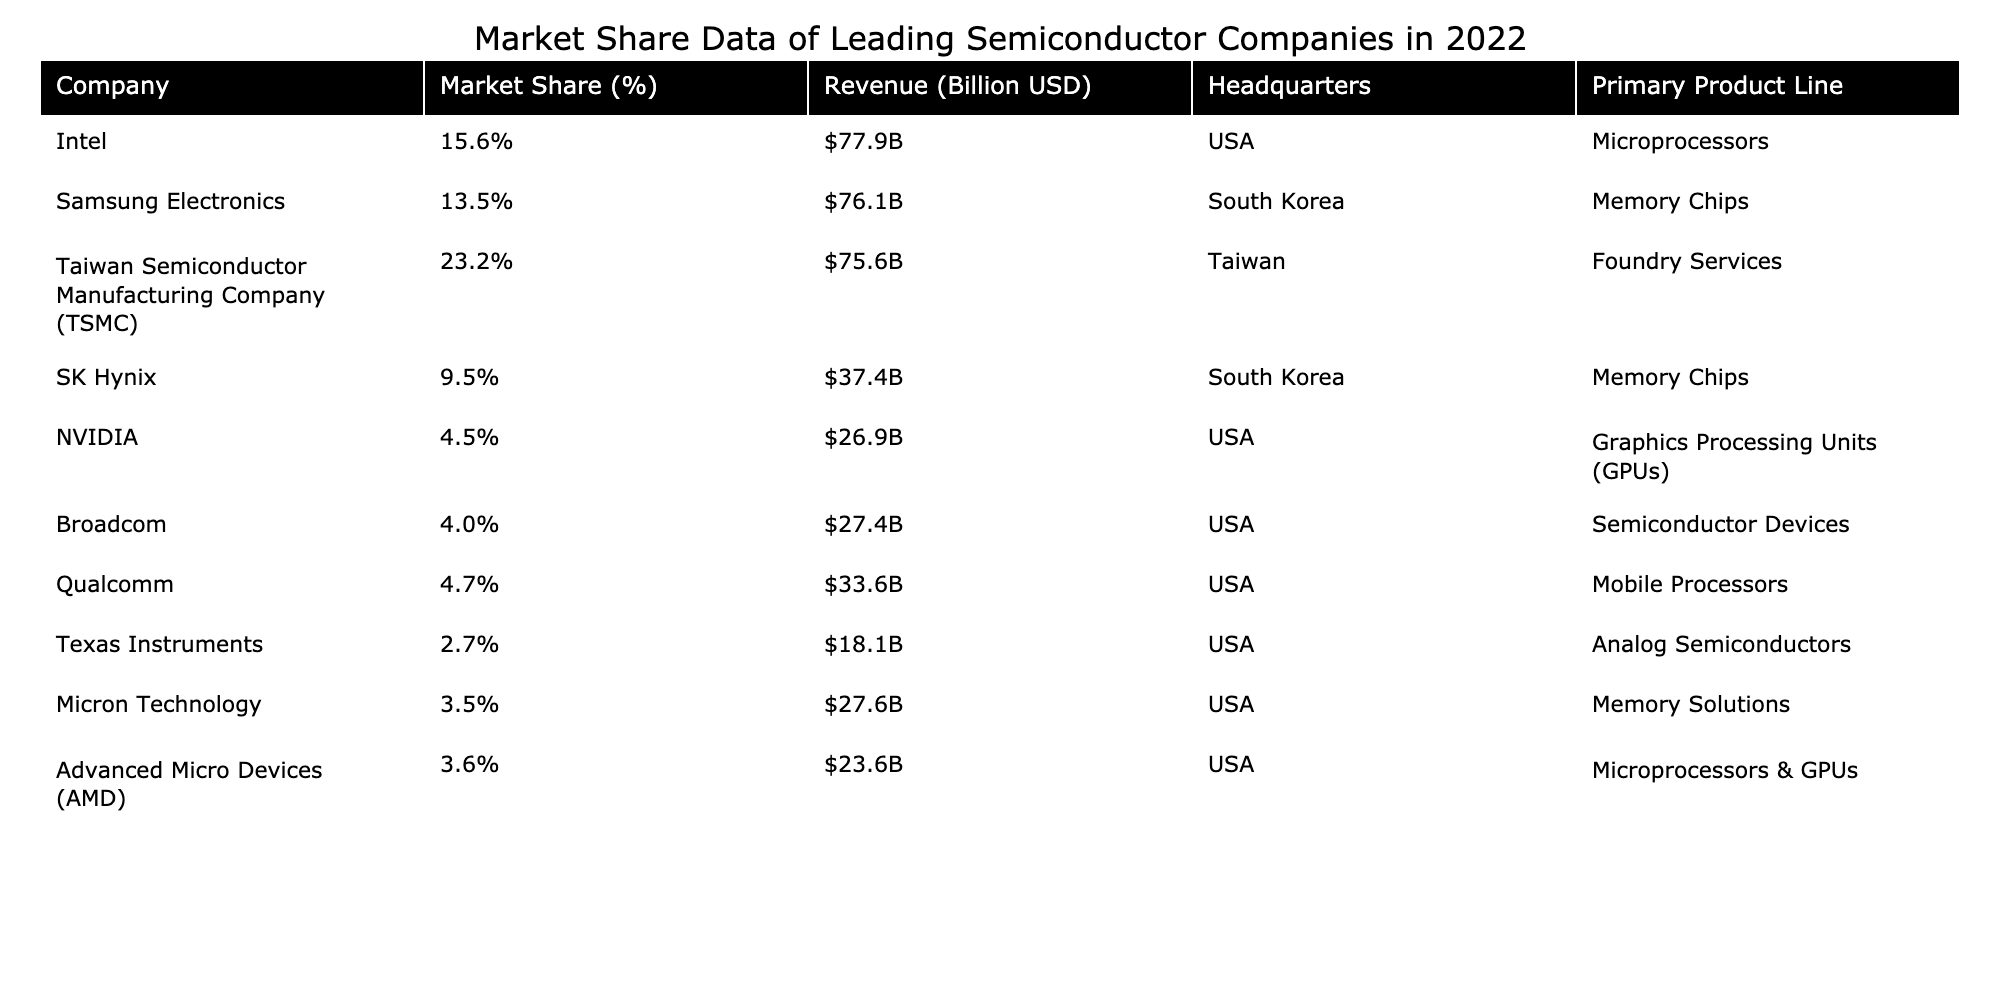What was the market share of Intel in 2022? The table indicates that Intel had a market share of 15.6% in 2022 as recorded in the "Market Share (%)" column.
Answer: 15.6% Which company had the highest revenue, and what was the amount? Reviewing the "Revenue (Billion USD)" column, Intel's revenue was the highest at $77.9 billion in 2022.
Answer: Intel, $77.9 billion Is TSMC's market share greater than that of Samsung Electronics? The market share for TSMC is 23.2%, while Samsung Electronics has 13.5%. Since 23.2% is greater than 13.5%, the answer is yes.
Answer: Yes What is the combined market share of NVIDIA and Qualcomm? NVIDIA has a market share of 4.5% and Qualcomm has 4.7%. The combined market share is 4.5 + 4.7 = 9.2%.
Answer: 9.2% Which company's primary product line is foundry services, and how much revenue did it generate? The table shows that Taiwan Semiconductor Manufacturing Company (TSMC) provides foundry services, and its revenue for 2022 was $75.6 billion as per the "Revenue (Billion USD)" column.
Answer: TSMC, $75.6 billion Which two companies have market shares below 5%, and what are their respective market shares? Looking at the market share percentages, Broadcom has 4.0% and NVIDIA has 4.5%, which are both below 5%.
Answer: Broadcom (4.0%), NVIDIA (4.5%) What is the difference in revenue between Samsung Electronics and SK Hynix? Samsung's revenue is $76.1 billion and SK Hynix's is $37.4 billion. The difference is 76.1 - 37.4 = 38.7 billion.
Answer: $38.7 billion Is the average revenue of the companies from South Korea higher than the average revenue of the companies from the USA? The total revenue for South Korean companies (Samsung Electronics, SK Hynix) is 76.1 + 37.4 = 113.5 billion with 2 companies, averaging 113.5/2 = 56.75 billion. For USA companies (Intel, NVIDIA, Broadcom, Qualcomm, Texas Instruments, Micron Technology, AMD), the total revenue is 77.9 + 26.9 + 27.4 + 33.6 + 18.1 + 27.6 + 23.6 = 234.1 billion with 7 companies, averaging 234.1/7 ≈ 33.4 billion. Since 56.75 billion > 33.4 billion, the average is higher for South Korea.
Answer: Yes What percentage of the total market share do the top three companies hold? The top three companies by market share are TSMC (23.2%), Intel (15.6%), and Samsung Electronics (13.5%). Their total market share is 23.2 + 15.6 + 13.5 = 52.3%.
Answer: 52.3% Which company has the smallest market share, and how much is it? Upon reviewing the market shares, Texas Instruments has the smallest market share at 2.7%.
Answer: Texas Instruments, 2.7% 